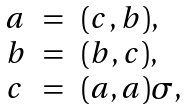Convert formula to latex. <formula><loc_0><loc_0><loc_500><loc_500>\begin{array} { l c l } a & = & ( c , b ) , \\ b & = & ( b , c ) , \\ c & = & ( a , a ) \sigma , \\ \end{array}</formula> 